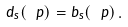<formula> <loc_0><loc_0><loc_500><loc_500>d _ { s } ( \ p ) = b _ { s } ( \ p ) \, .</formula> 